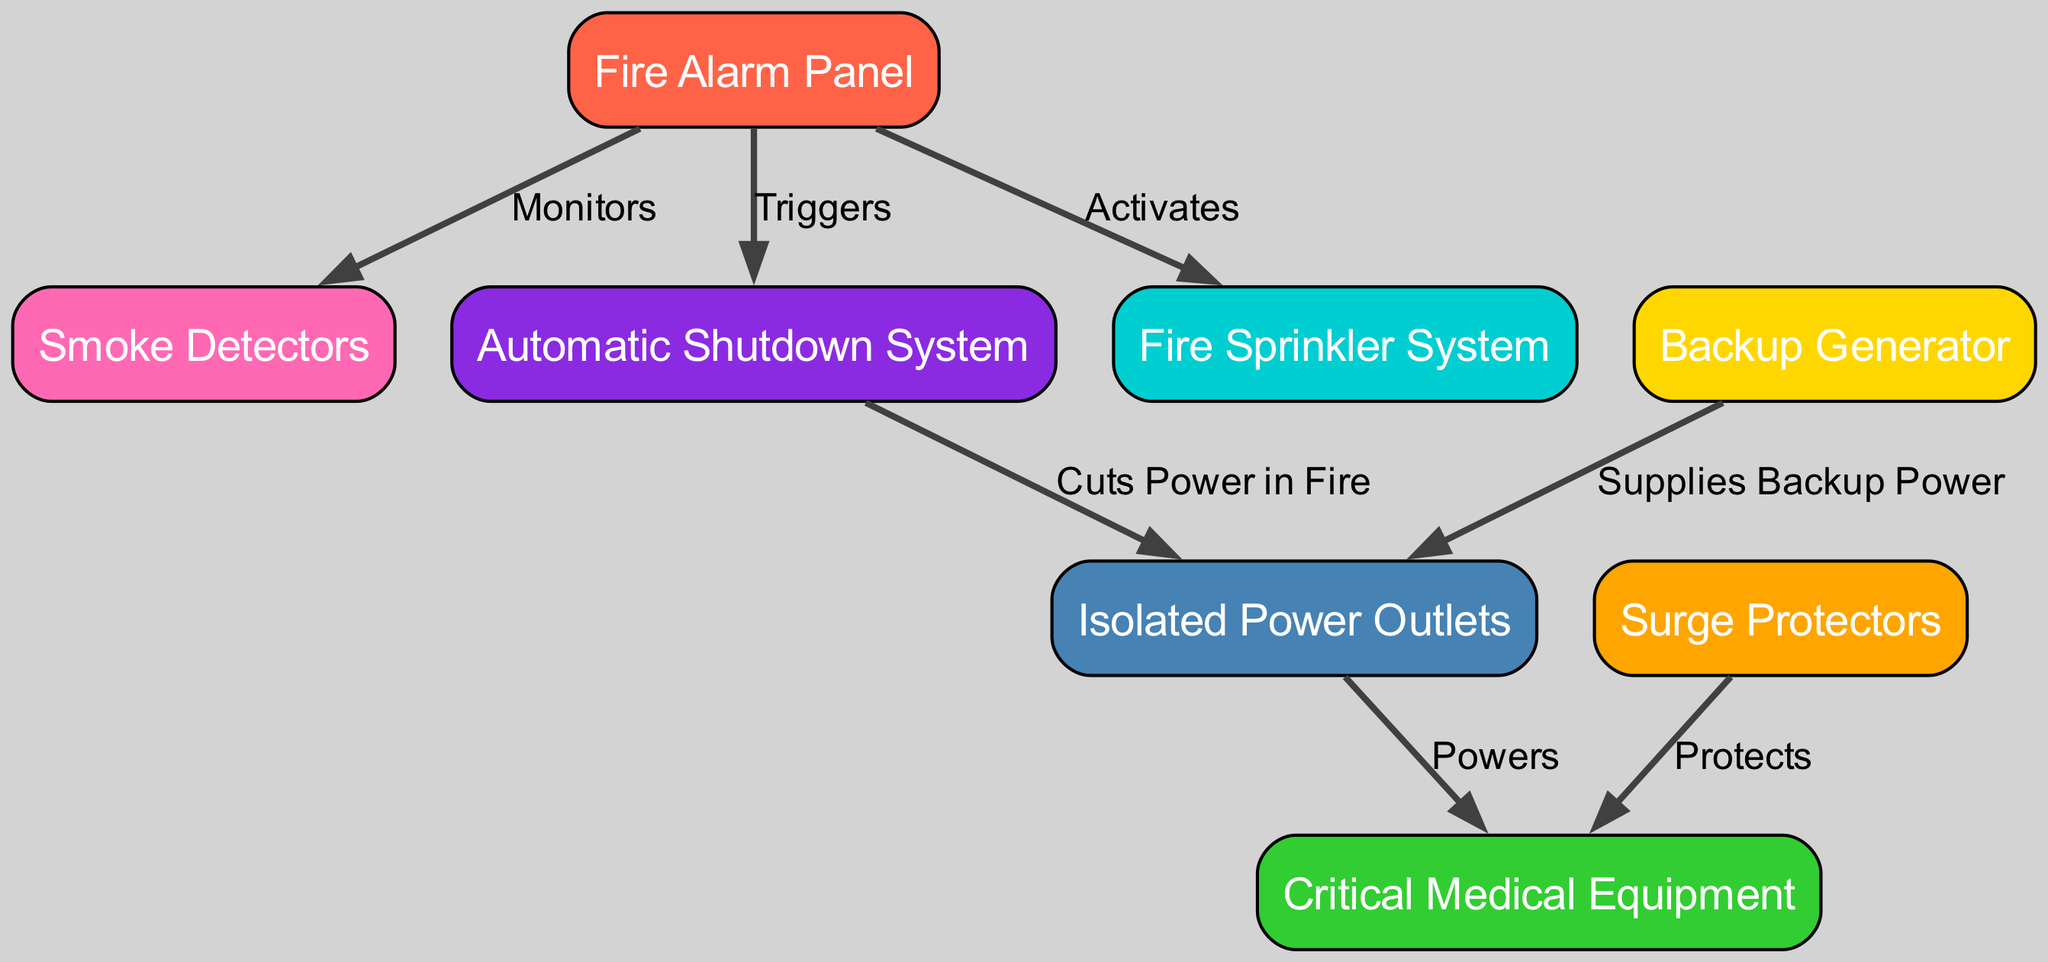What node is responsible for monitoring smoke levels? The diagram shows that the 'Fire Alarm Panel' is linked to the 'Smoke Detectors' with a 'Monitors' label. This indicates that the fire alarm panel monitors smoke levels through the smoke detectors.
Answer: Fire Alarm Panel How many edges connect the fire alarm panel? The fire alarm panel has three edges connected to different nodes: smoke detectors, automatic shutdown system, and fire sprinkler system. Counting these gives a total of three edges.
Answer: 3 What does the backup generator supply? The diagram indicates that the 'Backup Generator' supplies power to the 'Isolated Power Outlets'. This is shown by the directed edge labeled 'Supplies Backup Power'.
Answer: Isolated Power Outlets Which system is activated by the fire alarm panel? According to the diagram, the 'Fire Sprinkler System' is activated by the 'Fire Alarm Panel', as indicated by the edge labeled 'Activates'.
Answer: Fire Sprinkler System What action does the automatic shutdown system perform during a fire? The edge labeled 'Cuts Power in Fire' shows that the 'Automatic Shutdown System' cuts power to 'Isolated Power Outlets' during a fire.
Answer: Cuts Power How does the surge protector interact with medical equipment? The surge protector is connected to the medical equipment by an edge labeled 'Protects'. This indicates that the surge protector provides a protective function for the medical equipment.
Answer: Protects Which medical equipment is powered by isolated power outlets? The diagram shows a direct connection between 'Isolated Power Outlets' and 'Critical Medical Equipment' with the label 'Powers', indicating that it is the critical medical equipment that receives power from the isolated power outlets.
Answer: Critical Medical Equipment What happens to the isolated power outlets when a fire is detected? The 'Automatic Shutdown System' connects to the 'Isolated Power Outlets' with a label stating 'Cuts Power in Fire', which means that when a fire is detected, power to these outlets is cut to prevent further risk.
Answer: Cuts Power What is the relationship between smoke detectors and fire alarm panel? The label 'Monitors' from the edge connecting the 'Fire Alarm Panel' to the 'Smoke Detectors' indicates that the fire alarm panel is responsible for monitoring the smoke detectors.
Answer: Monitors 